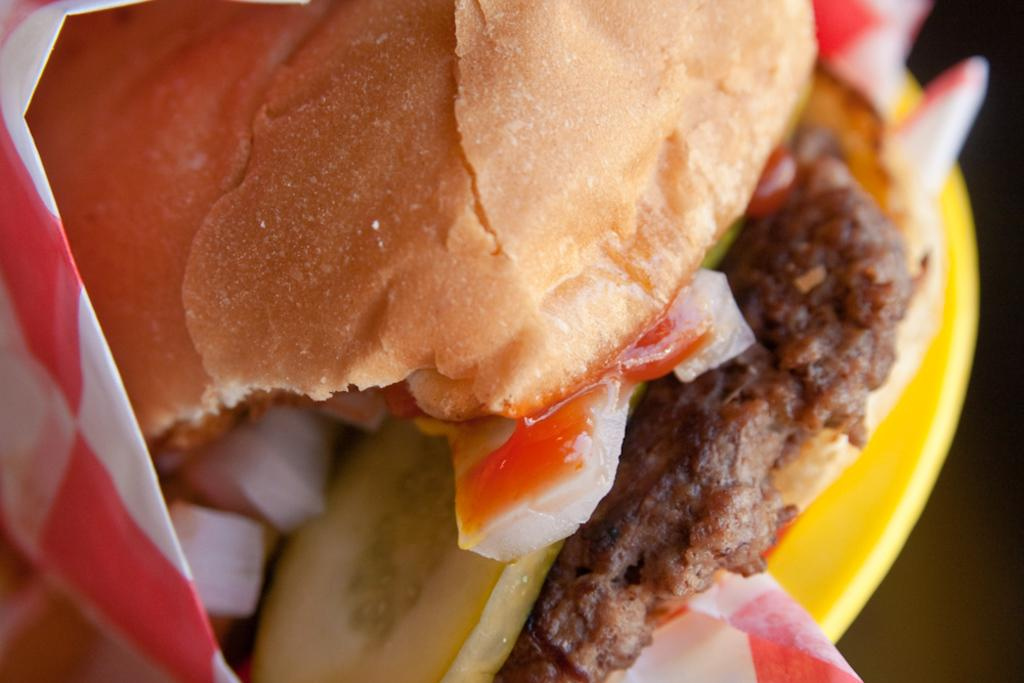What type of food can be seen in the image? The food in the image has brown and red colors. How is the food arranged in the image? The food is on a plate. What is the color of the plate? The plate has a yellow color. What type of pollution can be seen in the image? There is no pollution present in the image; it features food on a plate. What type of grass is growing on the plate in the image? There is no grass present on the plate in the image; it features food with brown and red colors on a yellow plate. 